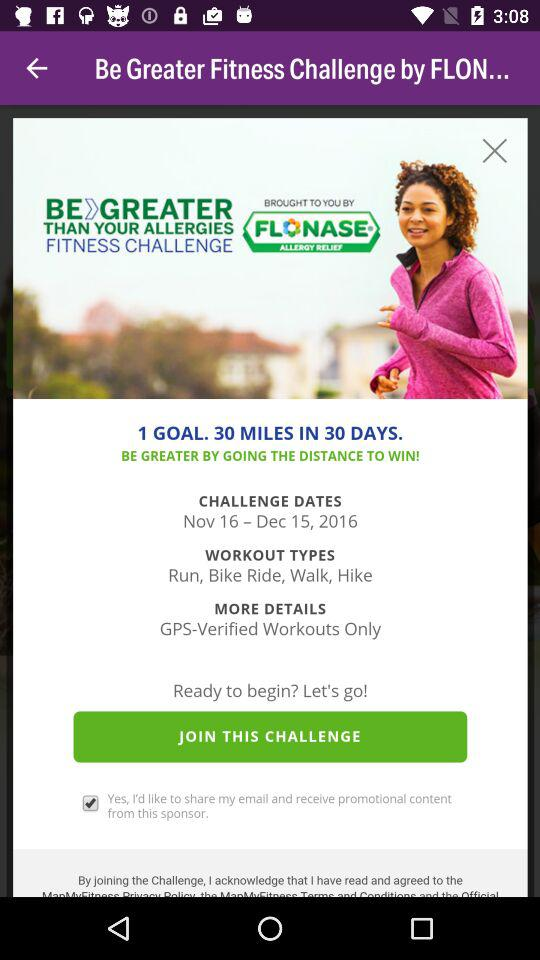What is the status of "Yes, I'd like to share my email and receive promotional content from this sponsor."? The status is "on". 